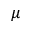<formula> <loc_0><loc_0><loc_500><loc_500>\mu</formula> 